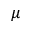<formula> <loc_0><loc_0><loc_500><loc_500>\mu</formula> 